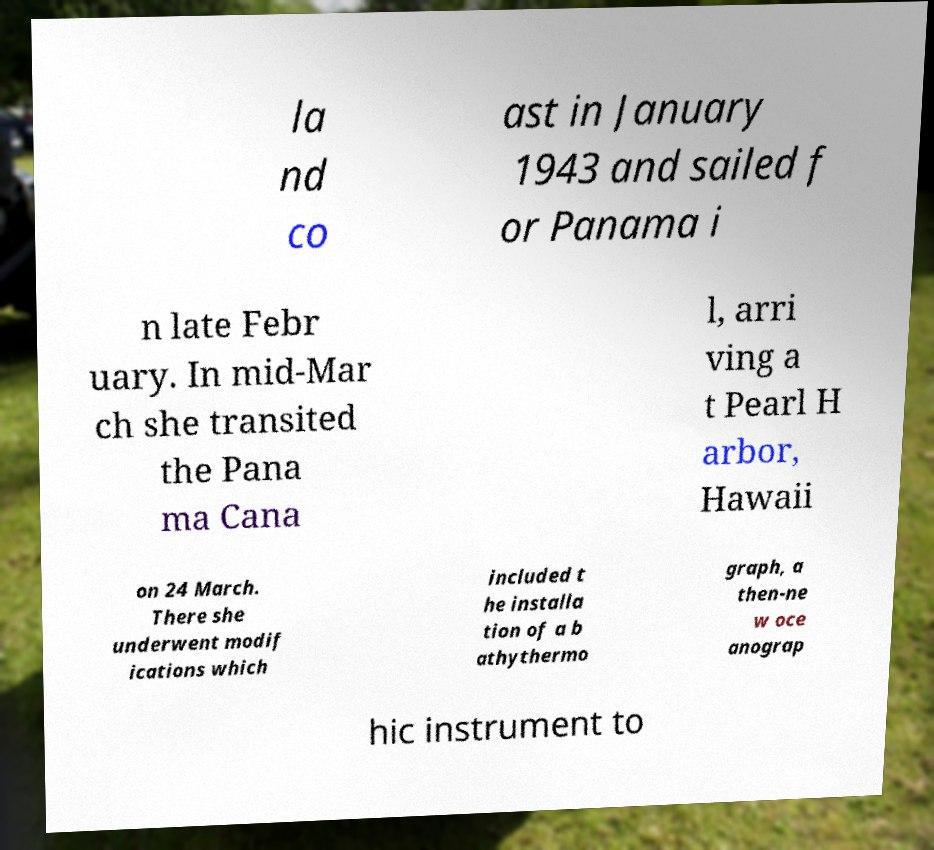Can you accurately transcribe the text from the provided image for me? la nd co ast in January 1943 and sailed f or Panama i n late Febr uary. In mid-Mar ch she transited the Pana ma Cana l, arri ving a t Pearl H arbor, Hawaii on 24 March. There she underwent modif ications which included t he installa tion of a b athythermo graph, a then-ne w oce anograp hic instrument to 